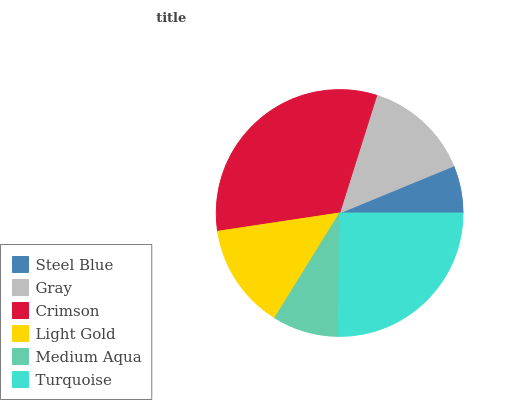Is Steel Blue the minimum?
Answer yes or no. Yes. Is Crimson the maximum?
Answer yes or no. Yes. Is Gray the minimum?
Answer yes or no. No. Is Gray the maximum?
Answer yes or no. No. Is Gray greater than Steel Blue?
Answer yes or no. Yes. Is Steel Blue less than Gray?
Answer yes or no. Yes. Is Steel Blue greater than Gray?
Answer yes or no. No. Is Gray less than Steel Blue?
Answer yes or no. No. Is Gray the high median?
Answer yes or no. Yes. Is Light Gold the low median?
Answer yes or no. Yes. Is Steel Blue the high median?
Answer yes or no. No. Is Steel Blue the low median?
Answer yes or no. No. 